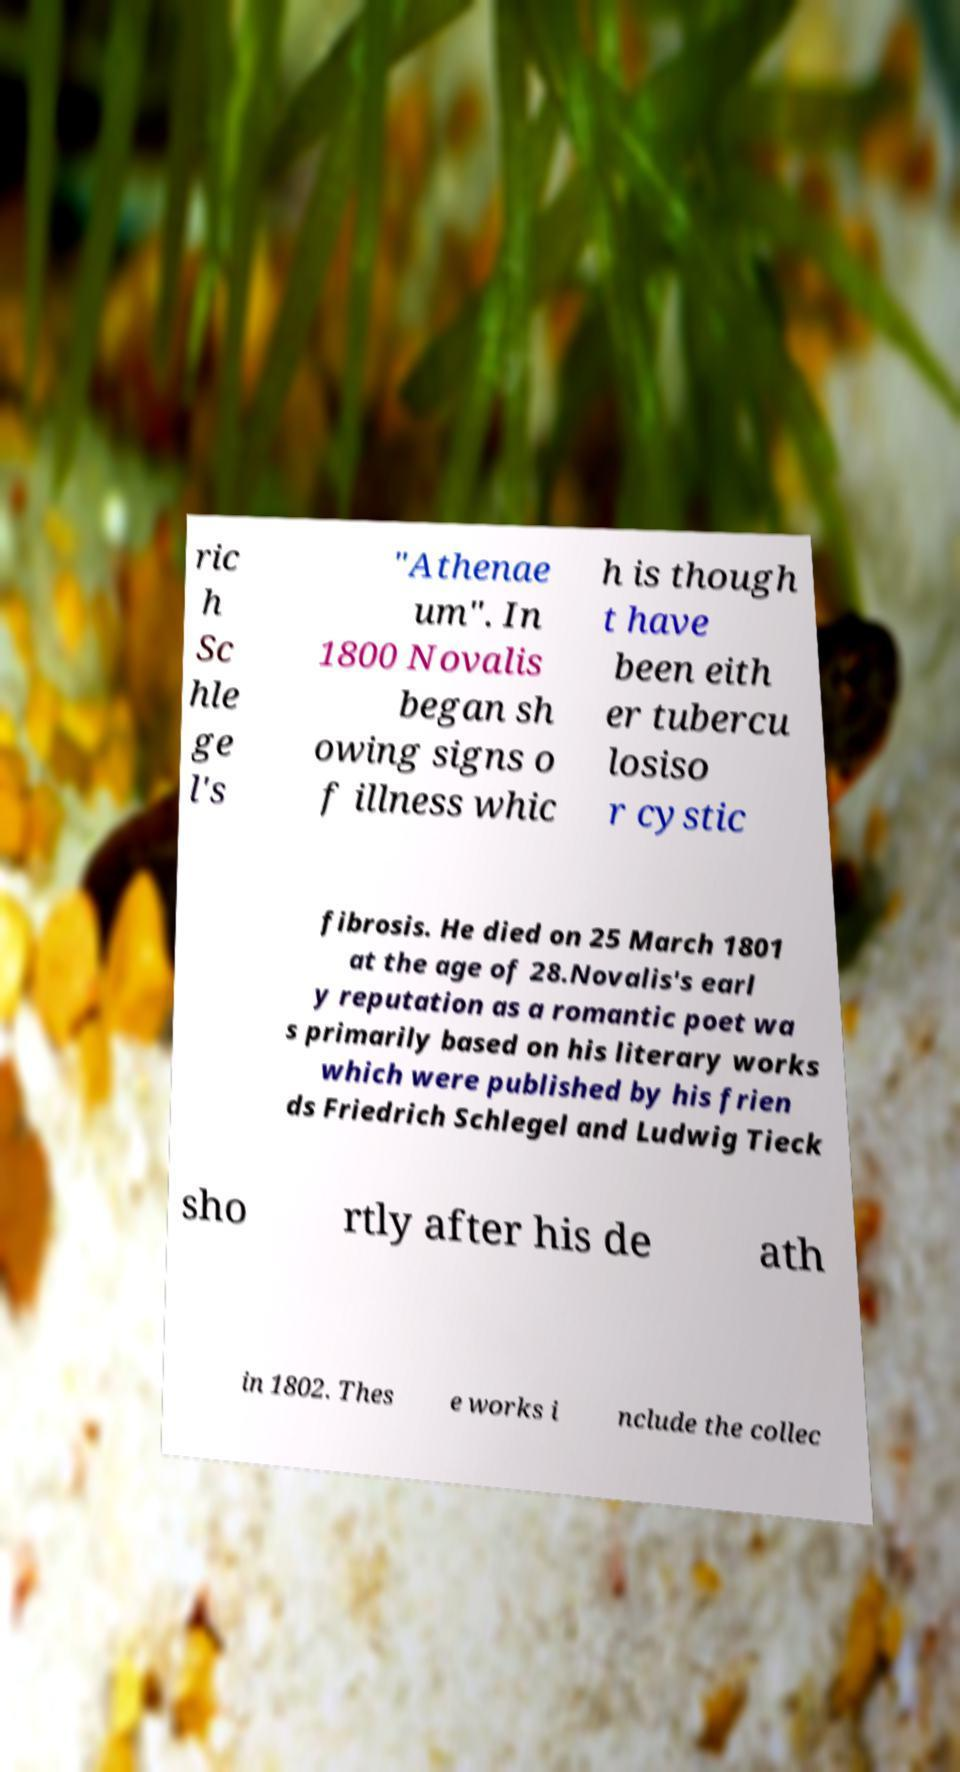For documentation purposes, I need the text within this image transcribed. Could you provide that? ric h Sc hle ge l's "Athenae um". In 1800 Novalis began sh owing signs o f illness whic h is though t have been eith er tubercu losiso r cystic fibrosis. He died on 25 March 1801 at the age of 28.Novalis's earl y reputation as a romantic poet wa s primarily based on his literary works which were published by his frien ds Friedrich Schlegel and Ludwig Tieck sho rtly after his de ath in 1802. Thes e works i nclude the collec 